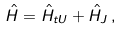<formula> <loc_0><loc_0><loc_500><loc_500>\hat { H } = \hat { H } _ { t U } + \hat { H } _ { J } \, ,</formula> 